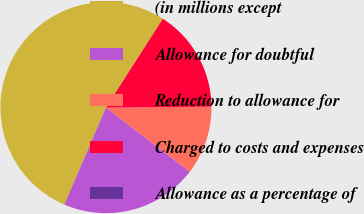Convert chart. <chart><loc_0><loc_0><loc_500><loc_500><pie_chart><fcel>(in millions except<fcel>Allowance for doubtful<fcel>Reduction to allowance for<fcel>Charged to costs and expenses<fcel>Allowance as a percentage of<nl><fcel>52.62%<fcel>21.05%<fcel>10.53%<fcel>15.79%<fcel>0.0%<nl></chart> 